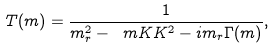Convert formula to latex. <formula><loc_0><loc_0><loc_500><loc_500>T ( m ) = \frac { 1 } { m ^ { 2 } _ { r } - \ m K K ^ { 2 } - i m _ { r } \Gamma ( m ) } ,</formula> 